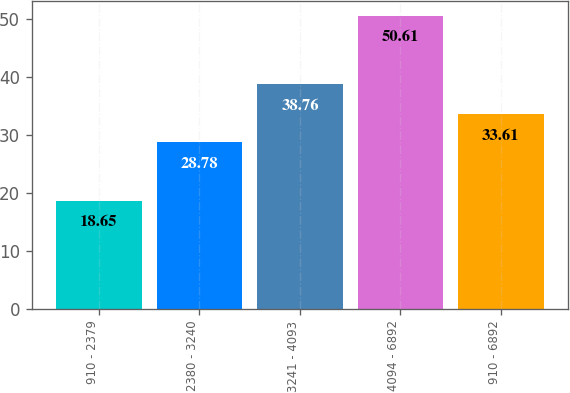Convert chart. <chart><loc_0><loc_0><loc_500><loc_500><bar_chart><fcel>910 - 2379<fcel>2380 - 3240<fcel>3241 - 4093<fcel>4094 - 6892<fcel>910 - 6892<nl><fcel>18.65<fcel>28.78<fcel>38.76<fcel>50.61<fcel>33.61<nl></chart> 